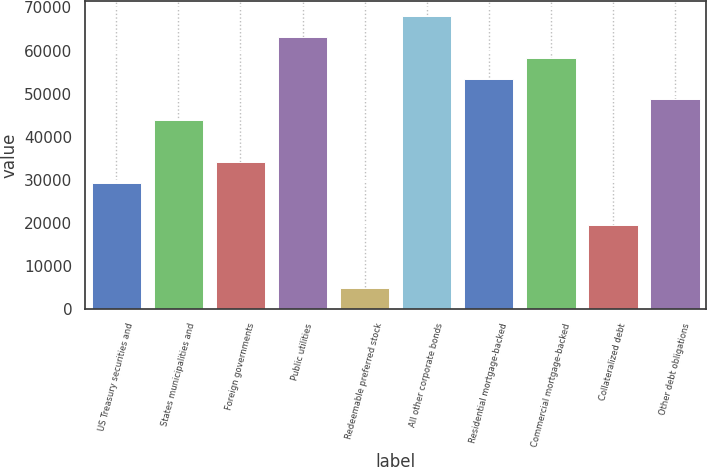Convert chart. <chart><loc_0><loc_0><loc_500><loc_500><bar_chart><fcel>US Treasury securities and<fcel>States municipalities and<fcel>Foreign governments<fcel>Public utilities<fcel>Redeemable preferred stock<fcel>All other corporate bonds<fcel>Residential mortgage-backed<fcel>Commercial mortgage-backed<fcel>Collateralized debt<fcel>Other debt obligations<nl><fcel>29187.7<fcel>43774.2<fcel>34049.9<fcel>63222.7<fcel>4877.04<fcel>68084.9<fcel>53498.4<fcel>58360.6<fcel>19463.5<fcel>48636.3<nl></chart> 